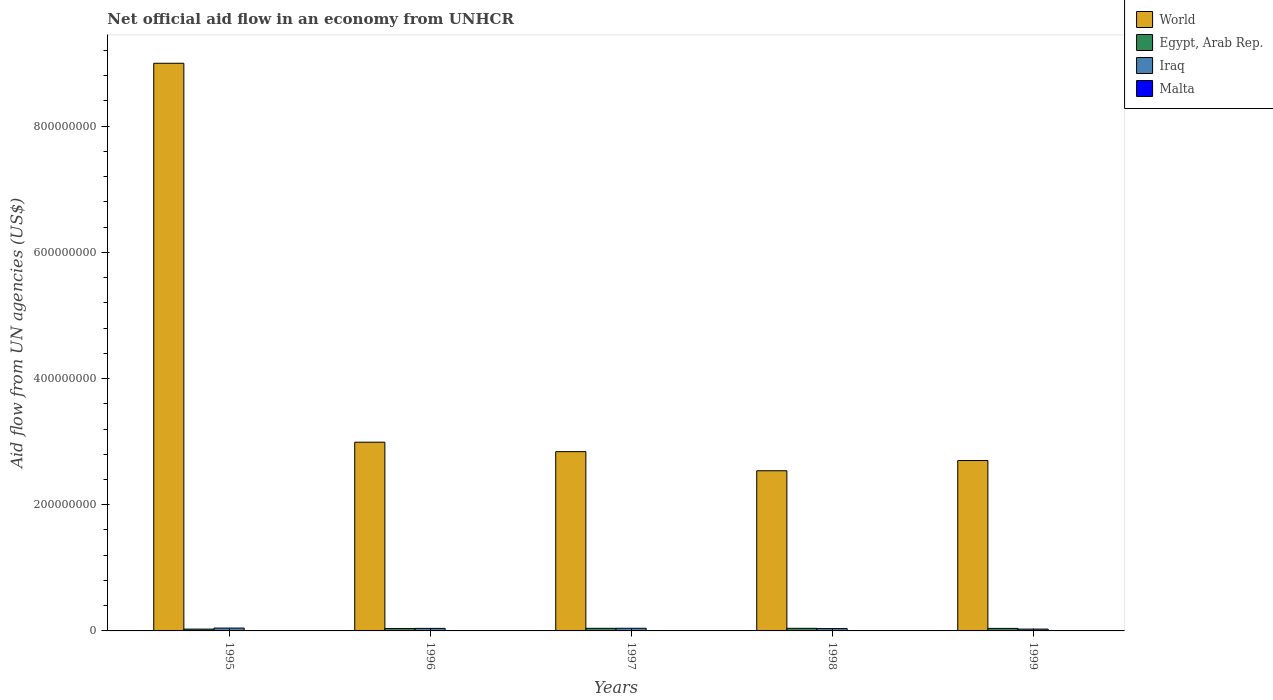How many different coloured bars are there?
Your answer should be compact. 4. How many groups of bars are there?
Offer a terse response. 5. Are the number of bars per tick equal to the number of legend labels?
Give a very brief answer. Yes. How many bars are there on the 1st tick from the right?
Your response must be concise. 4. In how many cases, is the number of bars for a given year not equal to the number of legend labels?
Offer a very short reply. 0. What is the net official aid flow in Egypt, Arab Rep. in 1997?
Provide a short and direct response. 4.14e+06. Across all years, what is the maximum net official aid flow in Malta?
Ensure brevity in your answer.  6.20e+05. Across all years, what is the minimum net official aid flow in Malta?
Keep it short and to the point. 2.20e+05. In which year was the net official aid flow in Malta minimum?
Your response must be concise. 1998. What is the total net official aid flow in Iraq in the graph?
Make the answer very short. 1.94e+07. What is the difference between the net official aid flow in World in 1995 and that in 1997?
Your response must be concise. 6.16e+08. What is the difference between the net official aid flow in Malta in 1998 and the net official aid flow in Egypt, Arab Rep. in 1997?
Give a very brief answer. -3.92e+06. What is the average net official aid flow in Egypt, Arab Rep. per year?
Provide a short and direct response. 3.80e+06. In the year 1999, what is the difference between the net official aid flow in Egypt, Arab Rep. and net official aid flow in World?
Keep it short and to the point. -2.66e+08. What is the ratio of the net official aid flow in World in 1995 to that in 1998?
Give a very brief answer. 3.54. Is the net official aid flow in Iraq in 1996 less than that in 1999?
Ensure brevity in your answer.  No. What is the difference between the highest and the second highest net official aid flow in Egypt, Arab Rep.?
Your answer should be compact. 10000. What is the difference between the highest and the lowest net official aid flow in World?
Offer a terse response. 6.46e+08. What does the 2nd bar from the left in 1999 represents?
Your answer should be very brief. Egypt, Arab Rep. What does the 2nd bar from the right in 1998 represents?
Your answer should be compact. Iraq. How many years are there in the graph?
Offer a very short reply. 5. Are the values on the major ticks of Y-axis written in scientific E-notation?
Offer a terse response. No. Does the graph contain grids?
Offer a very short reply. No. How many legend labels are there?
Offer a very short reply. 4. What is the title of the graph?
Give a very brief answer. Net official aid flow in an economy from UNHCR. What is the label or title of the Y-axis?
Ensure brevity in your answer.  Aid flow from UN agencies (US$). What is the Aid flow from UN agencies (US$) of World in 1995?
Give a very brief answer. 9.00e+08. What is the Aid flow from UN agencies (US$) of Egypt, Arab Rep. in 1995?
Provide a short and direct response. 2.89e+06. What is the Aid flow from UN agencies (US$) in Iraq in 1995?
Offer a very short reply. 4.51e+06. What is the Aid flow from UN agencies (US$) in Malta in 1995?
Provide a short and direct response. 6.20e+05. What is the Aid flow from UN agencies (US$) in World in 1996?
Keep it short and to the point. 2.99e+08. What is the Aid flow from UN agencies (US$) of Egypt, Arab Rep. in 1996?
Give a very brief answer. 3.86e+06. What is the Aid flow from UN agencies (US$) of Iraq in 1996?
Make the answer very short. 4.02e+06. What is the Aid flow from UN agencies (US$) of World in 1997?
Ensure brevity in your answer.  2.84e+08. What is the Aid flow from UN agencies (US$) in Egypt, Arab Rep. in 1997?
Make the answer very short. 4.14e+06. What is the Aid flow from UN agencies (US$) in Iraq in 1997?
Keep it short and to the point. 4.21e+06. What is the Aid flow from UN agencies (US$) in World in 1998?
Ensure brevity in your answer.  2.54e+08. What is the Aid flow from UN agencies (US$) of Egypt, Arab Rep. in 1998?
Provide a succinct answer. 4.13e+06. What is the Aid flow from UN agencies (US$) in Iraq in 1998?
Your answer should be compact. 3.70e+06. What is the Aid flow from UN agencies (US$) of World in 1999?
Your response must be concise. 2.70e+08. What is the Aid flow from UN agencies (US$) of Egypt, Arab Rep. in 1999?
Offer a very short reply. 3.99e+06. What is the Aid flow from UN agencies (US$) in Iraq in 1999?
Offer a terse response. 2.92e+06. What is the Aid flow from UN agencies (US$) in Malta in 1999?
Keep it short and to the point. 2.20e+05. Across all years, what is the maximum Aid flow from UN agencies (US$) of World?
Offer a terse response. 9.00e+08. Across all years, what is the maximum Aid flow from UN agencies (US$) of Egypt, Arab Rep.?
Make the answer very short. 4.14e+06. Across all years, what is the maximum Aid flow from UN agencies (US$) of Iraq?
Make the answer very short. 4.51e+06. Across all years, what is the maximum Aid flow from UN agencies (US$) in Malta?
Your answer should be very brief. 6.20e+05. Across all years, what is the minimum Aid flow from UN agencies (US$) of World?
Offer a very short reply. 2.54e+08. Across all years, what is the minimum Aid flow from UN agencies (US$) in Egypt, Arab Rep.?
Offer a very short reply. 2.89e+06. Across all years, what is the minimum Aid flow from UN agencies (US$) of Iraq?
Make the answer very short. 2.92e+06. Across all years, what is the minimum Aid flow from UN agencies (US$) in Malta?
Ensure brevity in your answer.  2.20e+05. What is the total Aid flow from UN agencies (US$) of World in the graph?
Your response must be concise. 2.01e+09. What is the total Aid flow from UN agencies (US$) in Egypt, Arab Rep. in the graph?
Keep it short and to the point. 1.90e+07. What is the total Aid flow from UN agencies (US$) of Iraq in the graph?
Offer a terse response. 1.94e+07. What is the total Aid flow from UN agencies (US$) in Malta in the graph?
Ensure brevity in your answer.  1.85e+06. What is the difference between the Aid flow from UN agencies (US$) of World in 1995 and that in 1996?
Keep it short and to the point. 6.01e+08. What is the difference between the Aid flow from UN agencies (US$) of Egypt, Arab Rep. in 1995 and that in 1996?
Provide a short and direct response. -9.70e+05. What is the difference between the Aid flow from UN agencies (US$) in Iraq in 1995 and that in 1996?
Provide a short and direct response. 4.90e+05. What is the difference between the Aid flow from UN agencies (US$) in World in 1995 and that in 1997?
Make the answer very short. 6.16e+08. What is the difference between the Aid flow from UN agencies (US$) of Egypt, Arab Rep. in 1995 and that in 1997?
Give a very brief answer. -1.25e+06. What is the difference between the Aid flow from UN agencies (US$) in World in 1995 and that in 1998?
Provide a succinct answer. 6.46e+08. What is the difference between the Aid flow from UN agencies (US$) of Egypt, Arab Rep. in 1995 and that in 1998?
Ensure brevity in your answer.  -1.24e+06. What is the difference between the Aid flow from UN agencies (US$) in Iraq in 1995 and that in 1998?
Your answer should be compact. 8.10e+05. What is the difference between the Aid flow from UN agencies (US$) in World in 1995 and that in 1999?
Provide a short and direct response. 6.30e+08. What is the difference between the Aid flow from UN agencies (US$) of Egypt, Arab Rep. in 1995 and that in 1999?
Make the answer very short. -1.10e+06. What is the difference between the Aid flow from UN agencies (US$) in Iraq in 1995 and that in 1999?
Offer a very short reply. 1.59e+06. What is the difference between the Aid flow from UN agencies (US$) in World in 1996 and that in 1997?
Your answer should be compact. 1.50e+07. What is the difference between the Aid flow from UN agencies (US$) of Egypt, Arab Rep. in 1996 and that in 1997?
Offer a very short reply. -2.80e+05. What is the difference between the Aid flow from UN agencies (US$) in Malta in 1996 and that in 1997?
Make the answer very short. 1.90e+05. What is the difference between the Aid flow from UN agencies (US$) of World in 1996 and that in 1998?
Make the answer very short. 4.53e+07. What is the difference between the Aid flow from UN agencies (US$) in Egypt, Arab Rep. in 1996 and that in 1998?
Ensure brevity in your answer.  -2.70e+05. What is the difference between the Aid flow from UN agencies (US$) of Iraq in 1996 and that in 1998?
Provide a succinct answer. 3.20e+05. What is the difference between the Aid flow from UN agencies (US$) in World in 1996 and that in 1999?
Give a very brief answer. 2.91e+07. What is the difference between the Aid flow from UN agencies (US$) in Egypt, Arab Rep. in 1996 and that in 1999?
Your response must be concise. -1.30e+05. What is the difference between the Aid flow from UN agencies (US$) of Iraq in 1996 and that in 1999?
Offer a terse response. 1.10e+06. What is the difference between the Aid flow from UN agencies (US$) in World in 1997 and that in 1998?
Ensure brevity in your answer.  3.03e+07. What is the difference between the Aid flow from UN agencies (US$) in Iraq in 1997 and that in 1998?
Give a very brief answer. 5.10e+05. What is the difference between the Aid flow from UN agencies (US$) in World in 1997 and that in 1999?
Give a very brief answer. 1.41e+07. What is the difference between the Aid flow from UN agencies (US$) in Iraq in 1997 and that in 1999?
Give a very brief answer. 1.29e+06. What is the difference between the Aid flow from UN agencies (US$) of World in 1998 and that in 1999?
Ensure brevity in your answer.  -1.62e+07. What is the difference between the Aid flow from UN agencies (US$) of Iraq in 1998 and that in 1999?
Your answer should be very brief. 7.80e+05. What is the difference between the Aid flow from UN agencies (US$) of World in 1995 and the Aid flow from UN agencies (US$) of Egypt, Arab Rep. in 1996?
Provide a short and direct response. 8.96e+08. What is the difference between the Aid flow from UN agencies (US$) of World in 1995 and the Aid flow from UN agencies (US$) of Iraq in 1996?
Keep it short and to the point. 8.96e+08. What is the difference between the Aid flow from UN agencies (US$) in World in 1995 and the Aid flow from UN agencies (US$) in Malta in 1996?
Provide a short and direct response. 8.99e+08. What is the difference between the Aid flow from UN agencies (US$) in Egypt, Arab Rep. in 1995 and the Aid flow from UN agencies (US$) in Iraq in 1996?
Offer a very short reply. -1.13e+06. What is the difference between the Aid flow from UN agencies (US$) of Egypt, Arab Rep. in 1995 and the Aid flow from UN agencies (US$) of Malta in 1996?
Keep it short and to the point. 2.40e+06. What is the difference between the Aid flow from UN agencies (US$) in Iraq in 1995 and the Aid flow from UN agencies (US$) in Malta in 1996?
Your answer should be very brief. 4.02e+06. What is the difference between the Aid flow from UN agencies (US$) of World in 1995 and the Aid flow from UN agencies (US$) of Egypt, Arab Rep. in 1997?
Make the answer very short. 8.96e+08. What is the difference between the Aid flow from UN agencies (US$) in World in 1995 and the Aid flow from UN agencies (US$) in Iraq in 1997?
Offer a very short reply. 8.96e+08. What is the difference between the Aid flow from UN agencies (US$) in World in 1995 and the Aid flow from UN agencies (US$) in Malta in 1997?
Offer a very short reply. 8.99e+08. What is the difference between the Aid flow from UN agencies (US$) in Egypt, Arab Rep. in 1995 and the Aid flow from UN agencies (US$) in Iraq in 1997?
Offer a terse response. -1.32e+06. What is the difference between the Aid flow from UN agencies (US$) of Egypt, Arab Rep. in 1995 and the Aid flow from UN agencies (US$) of Malta in 1997?
Keep it short and to the point. 2.59e+06. What is the difference between the Aid flow from UN agencies (US$) in Iraq in 1995 and the Aid flow from UN agencies (US$) in Malta in 1997?
Keep it short and to the point. 4.21e+06. What is the difference between the Aid flow from UN agencies (US$) in World in 1995 and the Aid flow from UN agencies (US$) in Egypt, Arab Rep. in 1998?
Give a very brief answer. 8.96e+08. What is the difference between the Aid flow from UN agencies (US$) in World in 1995 and the Aid flow from UN agencies (US$) in Iraq in 1998?
Provide a succinct answer. 8.96e+08. What is the difference between the Aid flow from UN agencies (US$) in World in 1995 and the Aid flow from UN agencies (US$) in Malta in 1998?
Your answer should be compact. 9.00e+08. What is the difference between the Aid flow from UN agencies (US$) of Egypt, Arab Rep. in 1995 and the Aid flow from UN agencies (US$) of Iraq in 1998?
Offer a very short reply. -8.10e+05. What is the difference between the Aid flow from UN agencies (US$) of Egypt, Arab Rep. in 1995 and the Aid flow from UN agencies (US$) of Malta in 1998?
Offer a very short reply. 2.67e+06. What is the difference between the Aid flow from UN agencies (US$) in Iraq in 1995 and the Aid flow from UN agencies (US$) in Malta in 1998?
Your answer should be compact. 4.29e+06. What is the difference between the Aid flow from UN agencies (US$) of World in 1995 and the Aid flow from UN agencies (US$) of Egypt, Arab Rep. in 1999?
Offer a terse response. 8.96e+08. What is the difference between the Aid flow from UN agencies (US$) of World in 1995 and the Aid flow from UN agencies (US$) of Iraq in 1999?
Give a very brief answer. 8.97e+08. What is the difference between the Aid flow from UN agencies (US$) in World in 1995 and the Aid flow from UN agencies (US$) in Malta in 1999?
Your answer should be compact. 9.00e+08. What is the difference between the Aid flow from UN agencies (US$) in Egypt, Arab Rep. in 1995 and the Aid flow from UN agencies (US$) in Malta in 1999?
Offer a terse response. 2.67e+06. What is the difference between the Aid flow from UN agencies (US$) of Iraq in 1995 and the Aid flow from UN agencies (US$) of Malta in 1999?
Offer a very short reply. 4.29e+06. What is the difference between the Aid flow from UN agencies (US$) of World in 1996 and the Aid flow from UN agencies (US$) of Egypt, Arab Rep. in 1997?
Keep it short and to the point. 2.95e+08. What is the difference between the Aid flow from UN agencies (US$) of World in 1996 and the Aid flow from UN agencies (US$) of Iraq in 1997?
Keep it short and to the point. 2.95e+08. What is the difference between the Aid flow from UN agencies (US$) in World in 1996 and the Aid flow from UN agencies (US$) in Malta in 1997?
Provide a succinct answer. 2.99e+08. What is the difference between the Aid flow from UN agencies (US$) of Egypt, Arab Rep. in 1996 and the Aid flow from UN agencies (US$) of Iraq in 1997?
Your response must be concise. -3.50e+05. What is the difference between the Aid flow from UN agencies (US$) of Egypt, Arab Rep. in 1996 and the Aid flow from UN agencies (US$) of Malta in 1997?
Your answer should be compact. 3.56e+06. What is the difference between the Aid flow from UN agencies (US$) in Iraq in 1996 and the Aid flow from UN agencies (US$) in Malta in 1997?
Offer a very short reply. 3.72e+06. What is the difference between the Aid flow from UN agencies (US$) in World in 1996 and the Aid flow from UN agencies (US$) in Egypt, Arab Rep. in 1998?
Keep it short and to the point. 2.95e+08. What is the difference between the Aid flow from UN agencies (US$) of World in 1996 and the Aid flow from UN agencies (US$) of Iraq in 1998?
Your answer should be very brief. 2.95e+08. What is the difference between the Aid flow from UN agencies (US$) in World in 1996 and the Aid flow from UN agencies (US$) in Malta in 1998?
Ensure brevity in your answer.  2.99e+08. What is the difference between the Aid flow from UN agencies (US$) of Egypt, Arab Rep. in 1996 and the Aid flow from UN agencies (US$) of Malta in 1998?
Make the answer very short. 3.64e+06. What is the difference between the Aid flow from UN agencies (US$) of Iraq in 1996 and the Aid flow from UN agencies (US$) of Malta in 1998?
Your response must be concise. 3.80e+06. What is the difference between the Aid flow from UN agencies (US$) in World in 1996 and the Aid flow from UN agencies (US$) in Egypt, Arab Rep. in 1999?
Offer a very short reply. 2.95e+08. What is the difference between the Aid flow from UN agencies (US$) in World in 1996 and the Aid flow from UN agencies (US$) in Iraq in 1999?
Offer a very short reply. 2.96e+08. What is the difference between the Aid flow from UN agencies (US$) of World in 1996 and the Aid flow from UN agencies (US$) of Malta in 1999?
Keep it short and to the point. 2.99e+08. What is the difference between the Aid flow from UN agencies (US$) of Egypt, Arab Rep. in 1996 and the Aid flow from UN agencies (US$) of Iraq in 1999?
Ensure brevity in your answer.  9.40e+05. What is the difference between the Aid flow from UN agencies (US$) in Egypt, Arab Rep. in 1996 and the Aid flow from UN agencies (US$) in Malta in 1999?
Your answer should be very brief. 3.64e+06. What is the difference between the Aid flow from UN agencies (US$) of Iraq in 1996 and the Aid flow from UN agencies (US$) of Malta in 1999?
Make the answer very short. 3.80e+06. What is the difference between the Aid flow from UN agencies (US$) of World in 1997 and the Aid flow from UN agencies (US$) of Egypt, Arab Rep. in 1998?
Make the answer very short. 2.80e+08. What is the difference between the Aid flow from UN agencies (US$) of World in 1997 and the Aid flow from UN agencies (US$) of Iraq in 1998?
Give a very brief answer. 2.80e+08. What is the difference between the Aid flow from UN agencies (US$) of World in 1997 and the Aid flow from UN agencies (US$) of Malta in 1998?
Your response must be concise. 2.84e+08. What is the difference between the Aid flow from UN agencies (US$) of Egypt, Arab Rep. in 1997 and the Aid flow from UN agencies (US$) of Malta in 1998?
Offer a very short reply. 3.92e+06. What is the difference between the Aid flow from UN agencies (US$) of Iraq in 1997 and the Aid flow from UN agencies (US$) of Malta in 1998?
Keep it short and to the point. 3.99e+06. What is the difference between the Aid flow from UN agencies (US$) in World in 1997 and the Aid flow from UN agencies (US$) in Egypt, Arab Rep. in 1999?
Your response must be concise. 2.80e+08. What is the difference between the Aid flow from UN agencies (US$) of World in 1997 and the Aid flow from UN agencies (US$) of Iraq in 1999?
Provide a short and direct response. 2.81e+08. What is the difference between the Aid flow from UN agencies (US$) of World in 1997 and the Aid flow from UN agencies (US$) of Malta in 1999?
Your answer should be compact. 2.84e+08. What is the difference between the Aid flow from UN agencies (US$) in Egypt, Arab Rep. in 1997 and the Aid flow from UN agencies (US$) in Iraq in 1999?
Your answer should be very brief. 1.22e+06. What is the difference between the Aid flow from UN agencies (US$) of Egypt, Arab Rep. in 1997 and the Aid flow from UN agencies (US$) of Malta in 1999?
Offer a terse response. 3.92e+06. What is the difference between the Aid flow from UN agencies (US$) of Iraq in 1997 and the Aid flow from UN agencies (US$) of Malta in 1999?
Your answer should be compact. 3.99e+06. What is the difference between the Aid flow from UN agencies (US$) of World in 1998 and the Aid flow from UN agencies (US$) of Egypt, Arab Rep. in 1999?
Provide a succinct answer. 2.50e+08. What is the difference between the Aid flow from UN agencies (US$) in World in 1998 and the Aid flow from UN agencies (US$) in Iraq in 1999?
Keep it short and to the point. 2.51e+08. What is the difference between the Aid flow from UN agencies (US$) of World in 1998 and the Aid flow from UN agencies (US$) of Malta in 1999?
Your response must be concise. 2.54e+08. What is the difference between the Aid flow from UN agencies (US$) of Egypt, Arab Rep. in 1998 and the Aid flow from UN agencies (US$) of Iraq in 1999?
Your answer should be very brief. 1.21e+06. What is the difference between the Aid flow from UN agencies (US$) in Egypt, Arab Rep. in 1998 and the Aid flow from UN agencies (US$) in Malta in 1999?
Make the answer very short. 3.91e+06. What is the difference between the Aid flow from UN agencies (US$) in Iraq in 1998 and the Aid flow from UN agencies (US$) in Malta in 1999?
Offer a very short reply. 3.48e+06. What is the average Aid flow from UN agencies (US$) of World per year?
Your answer should be compact. 4.01e+08. What is the average Aid flow from UN agencies (US$) of Egypt, Arab Rep. per year?
Offer a terse response. 3.80e+06. What is the average Aid flow from UN agencies (US$) of Iraq per year?
Your response must be concise. 3.87e+06. In the year 1995, what is the difference between the Aid flow from UN agencies (US$) in World and Aid flow from UN agencies (US$) in Egypt, Arab Rep.?
Ensure brevity in your answer.  8.97e+08. In the year 1995, what is the difference between the Aid flow from UN agencies (US$) of World and Aid flow from UN agencies (US$) of Iraq?
Ensure brevity in your answer.  8.95e+08. In the year 1995, what is the difference between the Aid flow from UN agencies (US$) of World and Aid flow from UN agencies (US$) of Malta?
Your answer should be compact. 8.99e+08. In the year 1995, what is the difference between the Aid flow from UN agencies (US$) in Egypt, Arab Rep. and Aid flow from UN agencies (US$) in Iraq?
Provide a succinct answer. -1.62e+06. In the year 1995, what is the difference between the Aid flow from UN agencies (US$) in Egypt, Arab Rep. and Aid flow from UN agencies (US$) in Malta?
Ensure brevity in your answer.  2.27e+06. In the year 1995, what is the difference between the Aid flow from UN agencies (US$) of Iraq and Aid flow from UN agencies (US$) of Malta?
Your answer should be compact. 3.89e+06. In the year 1996, what is the difference between the Aid flow from UN agencies (US$) of World and Aid flow from UN agencies (US$) of Egypt, Arab Rep.?
Your answer should be very brief. 2.95e+08. In the year 1996, what is the difference between the Aid flow from UN agencies (US$) in World and Aid flow from UN agencies (US$) in Iraq?
Make the answer very short. 2.95e+08. In the year 1996, what is the difference between the Aid flow from UN agencies (US$) of World and Aid flow from UN agencies (US$) of Malta?
Your answer should be very brief. 2.99e+08. In the year 1996, what is the difference between the Aid flow from UN agencies (US$) of Egypt, Arab Rep. and Aid flow from UN agencies (US$) of Malta?
Make the answer very short. 3.37e+06. In the year 1996, what is the difference between the Aid flow from UN agencies (US$) in Iraq and Aid flow from UN agencies (US$) in Malta?
Your answer should be compact. 3.53e+06. In the year 1997, what is the difference between the Aid flow from UN agencies (US$) of World and Aid flow from UN agencies (US$) of Egypt, Arab Rep.?
Offer a terse response. 2.80e+08. In the year 1997, what is the difference between the Aid flow from UN agencies (US$) in World and Aid flow from UN agencies (US$) in Iraq?
Offer a very short reply. 2.80e+08. In the year 1997, what is the difference between the Aid flow from UN agencies (US$) in World and Aid flow from UN agencies (US$) in Malta?
Your answer should be compact. 2.84e+08. In the year 1997, what is the difference between the Aid flow from UN agencies (US$) of Egypt, Arab Rep. and Aid flow from UN agencies (US$) of Iraq?
Your answer should be very brief. -7.00e+04. In the year 1997, what is the difference between the Aid flow from UN agencies (US$) in Egypt, Arab Rep. and Aid flow from UN agencies (US$) in Malta?
Your answer should be very brief. 3.84e+06. In the year 1997, what is the difference between the Aid flow from UN agencies (US$) of Iraq and Aid flow from UN agencies (US$) of Malta?
Give a very brief answer. 3.91e+06. In the year 1998, what is the difference between the Aid flow from UN agencies (US$) of World and Aid flow from UN agencies (US$) of Egypt, Arab Rep.?
Your answer should be very brief. 2.50e+08. In the year 1998, what is the difference between the Aid flow from UN agencies (US$) in World and Aid flow from UN agencies (US$) in Iraq?
Ensure brevity in your answer.  2.50e+08. In the year 1998, what is the difference between the Aid flow from UN agencies (US$) in World and Aid flow from UN agencies (US$) in Malta?
Make the answer very short. 2.54e+08. In the year 1998, what is the difference between the Aid flow from UN agencies (US$) in Egypt, Arab Rep. and Aid flow from UN agencies (US$) in Malta?
Give a very brief answer. 3.91e+06. In the year 1998, what is the difference between the Aid flow from UN agencies (US$) in Iraq and Aid flow from UN agencies (US$) in Malta?
Offer a very short reply. 3.48e+06. In the year 1999, what is the difference between the Aid flow from UN agencies (US$) in World and Aid flow from UN agencies (US$) in Egypt, Arab Rep.?
Provide a succinct answer. 2.66e+08. In the year 1999, what is the difference between the Aid flow from UN agencies (US$) of World and Aid flow from UN agencies (US$) of Iraq?
Offer a terse response. 2.67e+08. In the year 1999, what is the difference between the Aid flow from UN agencies (US$) in World and Aid flow from UN agencies (US$) in Malta?
Ensure brevity in your answer.  2.70e+08. In the year 1999, what is the difference between the Aid flow from UN agencies (US$) in Egypt, Arab Rep. and Aid flow from UN agencies (US$) in Iraq?
Provide a short and direct response. 1.07e+06. In the year 1999, what is the difference between the Aid flow from UN agencies (US$) of Egypt, Arab Rep. and Aid flow from UN agencies (US$) of Malta?
Ensure brevity in your answer.  3.77e+06. In the year 1999, what is the difference between the Aid flow from UN agencies (US$) in Iraq and Aid flow from UN agencies (US$) in Malta?
Make the answer very short. 2.70e+06. What is the ratio of the Aid flow from UN agencies (US$) in World in 1995 to that in 1996?
Give a very brief answer. 3.01. What is the ratio of the Aid flow from UN agencies (US$) of Egypt, Arab Rep. in 1995 to that in 1996?
Your answer should be very brief. 0.75. What is the ratio of the Aid flow from UN agencies (US$) of Iraq in 1995 to that in 1996?
Give a very brief answer. 1.12. What is the ratio of the Aid flow from UN agencies (US$) of Malta in 1995 to that in 1996?
Offer a very short reply. 1.27. What is the ratio of the Aid flow from UN agencies (US$) of World in 1995 to that in 1997?
Offer a very short reply. 3.17. What is the ratio of the Aid flow from UN agencies (US$) in Egypt, Arab Rep. in 1995 to that in 1997?
Your answer should be compact. 0.7. What is the ratio of the Aid flow from UN agencies (US$) of Iraq in 1995 to that in 1997?
Provide a succinct answer. 1.07. What is the ratio of the Aid flow from UN agencies (US$) of Malta in 1995 to that in 1997?
Give a very brief answer. 2.07. What is the ratio of the Aid flow from UN agencies (US$) in World in 1995 to that in 1998?
Keep it short and to the point. 3.54. What is the ratio of the Aid flow from UN agencies (US$) in Egypt, Arab Rep. in 1995 to that in 1998?
Your answer should be very brief. 0.7. What is the ratio of the Aid flow from UN agencies (US$) of Iraq in 1995 to that in 1998?
Offer a very short reply. 1.22. What is the ratio of the Aid flow from UN agencies (US$) in Malta in 1995 to that in 1998?
Provide a succinct answer. 2.82. What is the ratio of the Aid flow from UN agencies (US$) in World in 1995 to that in 1999?
Keep it short and to the point. 3.33. What is the ratio of the Aid flow from UN agencies (US$) of Egypt, Arab Rep. in 1995 to that in 1999?
Keep it short and to the point. 0.72. What is the ratio of the Aid flow from UN agencies (US$) of Iraq in 1995 to that in 1999?
Keep it short and to the point. 1.54. What is the ratio of the Aid flow from UN agencies (US$) of Malta in 1995 to that in 1999?
Make the answer very short. 2.82. What is the ratio of the Aid flow from UN agencies (US$) in World in 1996 to that in 1997?
Your response must be concise. 1.05. What is the ratio of the Aid flow from UN agencies (US$) in Egypt, Arab Rep. in 1996 to that in 1997?
Provide a short and direct response. 0.93. What is the ratio of the Aid flow from UN agencies (US$) of Iraq in 1996 to that in 1997?
Your answer should be very brief. 0.95. What is the ratio of the Aid flow from UN agencies (US$) in Malta in 1996 to that in 1997?
Offer a very short reply. 1.63. What is the ratio of the Aid flow from UN agencies (US$) of World in 1996 to that in 1998?
Offer a very short reply. 1.18. What is the ratio of the Aid flow from UN agencies (US$) in Egypt, Arab Rep. in 1996 to that in 1998?
Provide a short and direct response. 0.93. What is the ratio of the Aid flow from UN agencies (US$) in Iraq in 1996 to that in 1998?
Make the answer very short. 1.09. What is the ratio of the Aid flow from UN agencies (US$) in Malta in 1996 to that in 1998?
Keep it short and to the point. 2.23. What is the ratio of the Aid flow from UN agencies (US$) of World in 1996 to that in 1999?
Ensure brevity in your answer.  1.11. What is the ratio of the Aid flow from UN agencies (US$) of Egypt, Arab Rep. in 1996 to that in 1999?
Provide a short and direct response. 0.97. What is the ratio of the Aid flow from UN agencies (US$) in Iraq in 1996 to that in 1999?
Offer a terse response. 1.38. What is the ratio of the Aid flow from UN agencies (US$) of Malta in 1996 to that in 1999?
Offer a terse response. 2.23. What is the ratio of the Aid flow from UN agencies (US$) in World in 1997 to that in 1998?
Make the answer very short. 1.12. What is the ratio of the Aid flow from UN agencies (US$) in Iraq in 1997 to that in 1998?
Give a very brief answer. 1.14. What is the ratio of the Aid flow from UN agencies (US$) of Malta in 1997 to that in 1998?
Ensure brevity in your answer.  1.36. What is the ratio of the Aid flow from UN agencies (US$) of World in 1997 to that in 1999?
Give a very brief answer. 1.05. What is the ratio of the Aid flow from UN agencies (US$) of Egypt, Arab Rep. in 1997 to that in 1999?
Your answer should be compact. 1.04. What is the ratio of the Aid flow from UN agencies (US$) in Iraq in 1997 to that in 1999?
Your answer should be very brief. 1.44. What is the ratio of the Aid flow from UN agencies (US$) in Malta in 1997 to that in 1999?
Give a very brief answer. 1.36. What is the ratio of the Aid flow from UN agencies (US$) of World in 1998 to that in 1999?
Make the answer very short. 0.94. What is the ratio of the Aid flow from UN agencies (US$) of Egypt, Arab Rep. in 1998 to that in 1999?
Your answer should be very brief. 1.04. What is the ratio of the Aid flow from UN agencies (US$) of Iraq in 1998 to that in 1999?
Your answer should be very brief. 1.27. What is the difference between the highest and the second highest Aid flow from UN agencies (US$) in World?
Offer a terse response. 6.01e+08. What is the difference between the highest and the second highest Aid flow from UN agencies (US$) in Malta?
Provide a succinct answer. 1.30e+05. What is the difference between the highest and the lowest Aid flow from UN agencies (US$) in World?
Keep it short and to the point. 6.46e+08. What is the difference between the highest and the lowest Aid flow from UN agencies (US$) in Egypt, Arab Rep.?
Ensure brevity in your answer.  1.25e+06. What is the difference between the highest and the lowest Aid flow from UN agencies (US$) in Iraq?
Keep it short and to the point. 1.59e+06. What is the difference between the highest and the lowest Aid flow from UN agencies (US$) in Malta?
Your answer should be compact. 4.00e+05. 